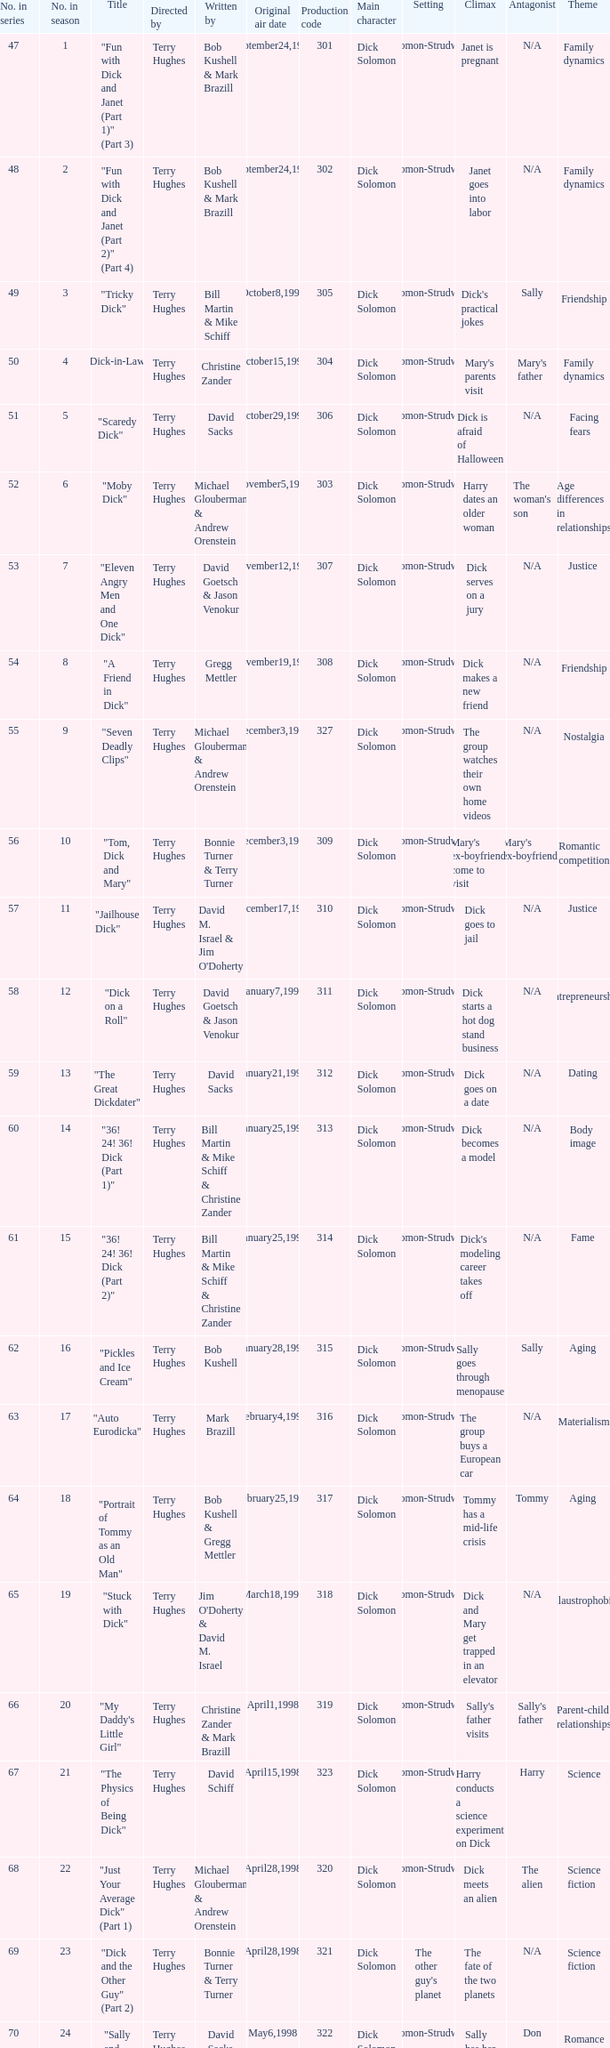What is the title of episode 10? "Tom, Dick and Mary". 